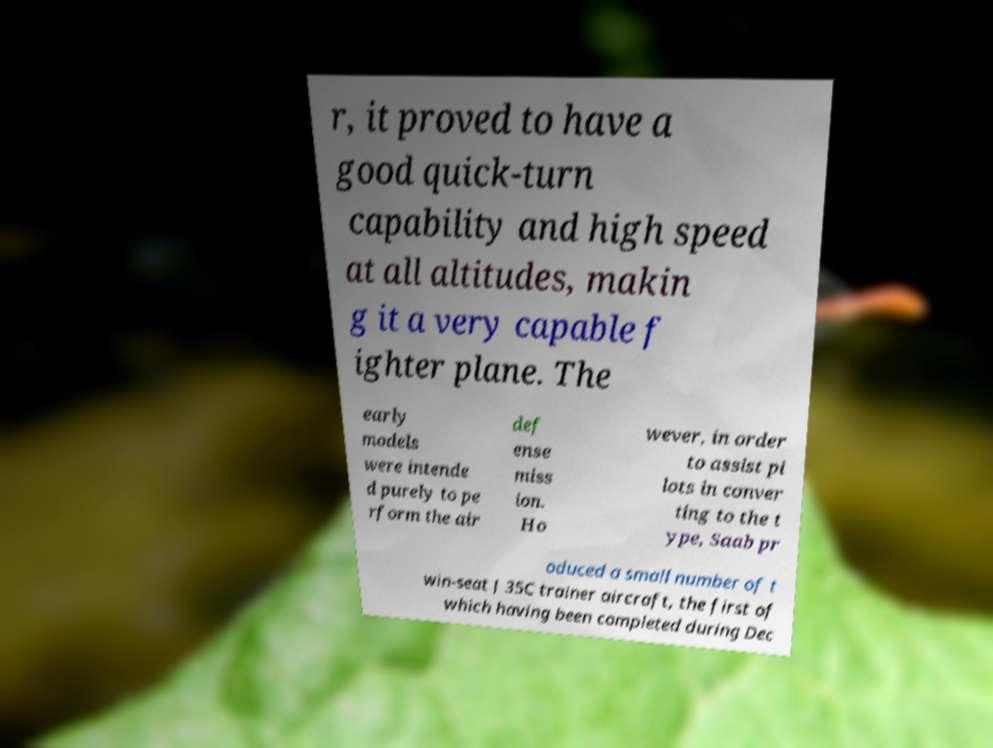Can you read and provide the text displayed in the image?This photo seems to have some interesting text. Can you extract and type it out for me? r, it proved to have a good quick-turn capability and high speed at all altitudes, makin g it a very capable f ighter plane. The early models were intende d purely to pe rform the air def ense miss ion. Ho wever, in order to assist pi lots in conver ting to the t ype, Saab pr oduced a small number of t win-seat J 35C trainer aircraft, the first of which having been completed during Dec 